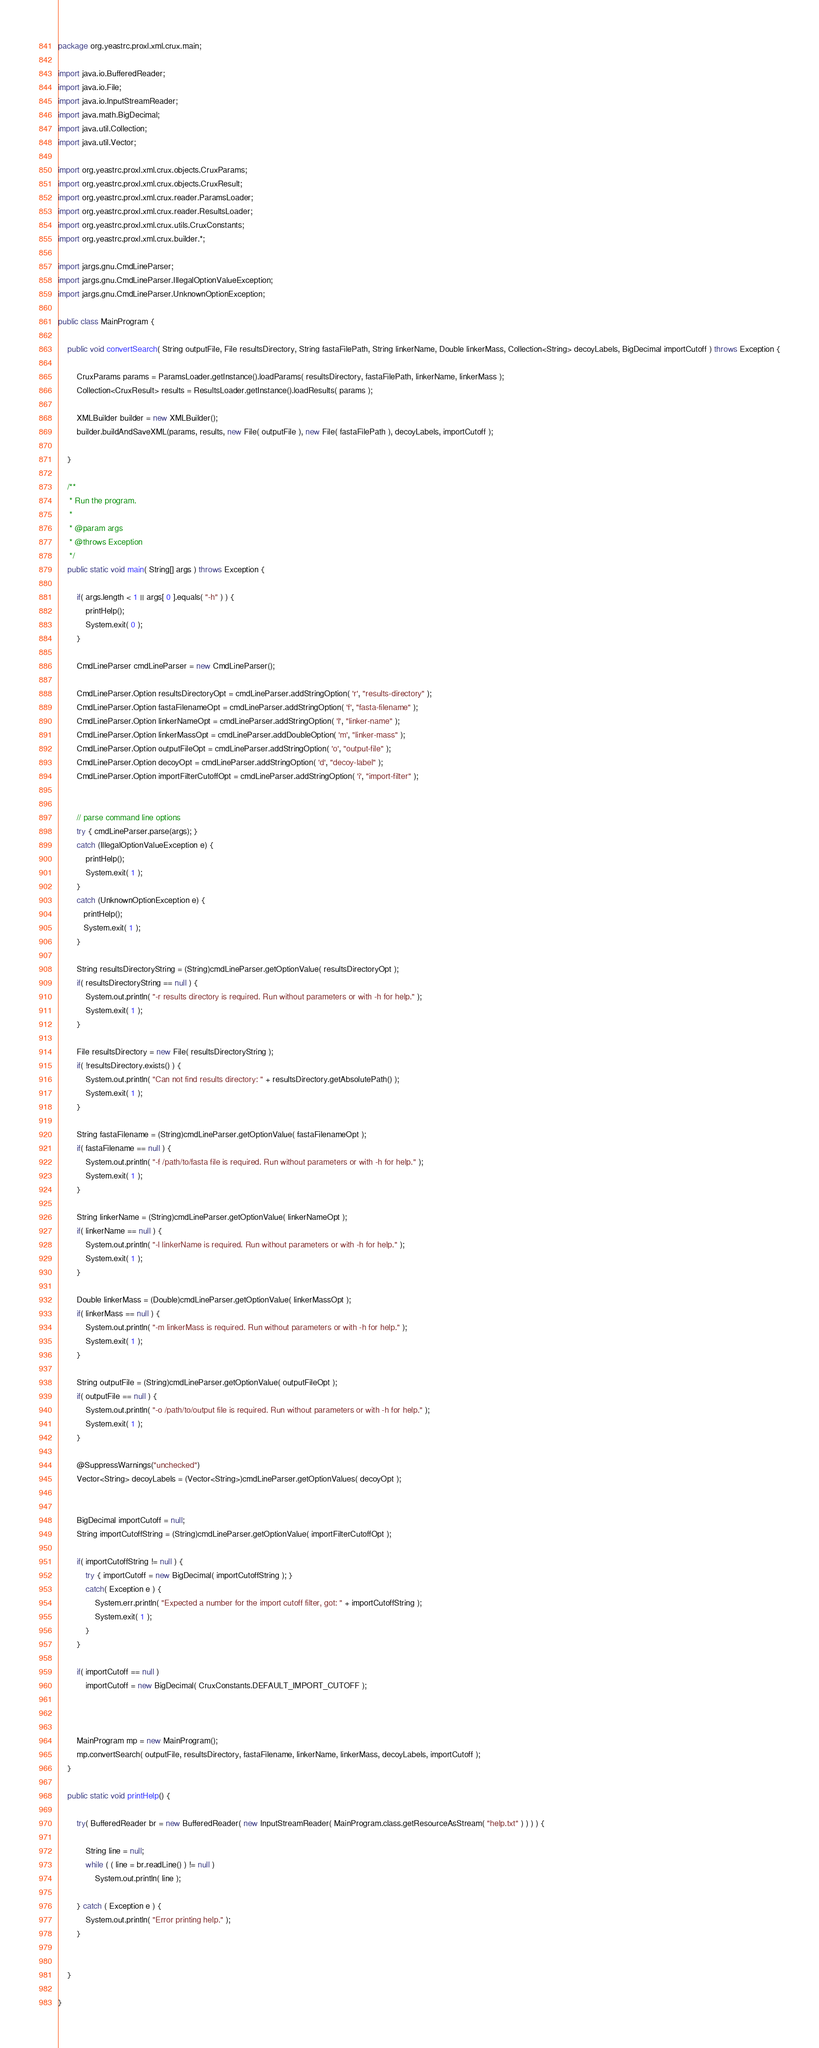Convert code to text. <code><loc_0><loc_0><loc_500><loc_500><_Java_>package org.yeastrc.proxl.xml.crux.main;

import java.io.BufferedReader;
import java.io.File;
import java.io.InputStreamReader;
import java.math.BigDecimal;
import java.util.Collection;
import java.util.Vector;

import org.yeastrc.proxl.xml.crux.objects.CruxParams;
import org.yeastrc.proxl.xml.crux.objects.CruxResult;
import org.yeastrc.proxl.xml.crux.reader.ParamsLoader;
import org.yeastrc.proxl.xml.crux.reader.ResultsLoader;
import org.yeastrc.proxl.xml.crux.utils.CruxConstants;
import org.yeastrc.proxl.xml.crux.builder.*;

import jargs.gnu.CmdLineParser;
import jargs.gnu.CmdLineParser.IllegalOptionValueException;
import jargs.gnu.CmdLineParser.UnknownOptionException;

public class MainProgram {

	public void convertSearch( String outputFile, File resultsDirectory, String fastaFilePath, String linkerName, Double linkerMass, Collection<String> decoyLabels, BigDecimal importCutoff ) throws Exception {
		
		CruxParams params = ParamsLoader.getInstance().loadParams( resultsDirectory, fastaFilePath, linkerName, linkerMass );
		Collection<CruxResult> results = ResultsLoader.getInstance().loadResults( params );
		
		XMLBuilder builder = new XMLBuilder();
		builder.buildAndSaveXML(params, results, new File( outputFile ), new File( fastaFilePath ), decoyLabels, importCutoff ); 
		
	}
	
	/**
	 * Run the program.
	 * 
	 * @param args
	 * @throws Exception
	 */
	public static void main( String[] args ) throws Exception {
		
		if( args.length < 1 || args[ 0 ].equals( "-h" ) ) {
			printHelp();
			System.exit( 0 );
		}
		
		CmdLineParser cmdLineParser = new CmdLineParser();
        
		CmdLineParser.Option resultsDirectoryOpt = cmdLineParser.addStringOption( 'r', "results-directory" );	
		CmdLineParser.Option fastaFilenameOpt = cmdLineParser.addStringOption( 'f', "fasta-filename" );	
		CmdLineParser.Option linkerNameOpt = cmdLineParser.addStringOption( 'l', "linker-name" );	
		CmdLineParser.Option linkerMassOpt = cmdLineParser.addDoubleOption( 'm', "linker-mass" );
		CmdLineParser.Option outputFileOpt = cmdLineParser.addStringOption( 'o', "output-file" );	
		CmdLineParser.Option decoyOpt = cmdLineParser.addStringOption( 'd', "decoy-label" );	
		CmdLineParser.Option importFilterCutoffOpt = cmdLineParser.addStringOption( 'i', "import-filter" );


        // parse command line options
        try { cmdLineParser.parse(args); }
        catch (IllegalOptionValueException e) {
        	printHelp();
            System.exit( 1 );
        }
        catch (UnknownOptionException e) {
           printHelp();
           System.exit( 1 );
        }
        
        String resultsDirectoryString = (String)cmdLineParser.getOptionValue( resultsDirectoryOpt );
        if( resultsDirectoryString == null ) {
        	System.out.println( "-r results directory is required. Run without parameters or with -h for help." );
        	System.exit( 1 );
        }
        
        File resultsDirectory = new File( resultsDirectoryString );
        if( !resultsDirectory.exists() ) {
        	System.out.println( "Can not find results directory: " + resultsDirectory.getAbsolutePath() );
        	System.exit( 1 );
        }
        
        String fastaFilename = (String)cmdLineParser.getOptionValue( fastaFilenameOpt );
        if( fastaFilename == null ) {
        	System.out.println( "-f /path/to/fasta file is required. Run without parameters or with -h for help." );
        	System.exit( 1 );
        }
        
        String linkerName = (String)cmdLineParser.getOptionValue( linkerNameOpt );
        if( linkerName == null ) {
        	System.out.println( "-l linkerName is required. Run without parameters or with -h for help." );
        	System.exit( 1 );
        }
        
        Double linkerMass = (Double)cmdLineParser.getOptionValue( linkerMassOpt );
        if( linkerMass == null ) {
        	System.out.println( "-m linkerMass is required. Run without parameters or with -h for help." );
        	System.exit( 1 );
        }
        
        String outputFile = (String)cmdLineParser.getOptionValue( outputFileOpt );
        if( outputFile == null ) {
        	System.out.println( "-o /path/to/output file is required. Run without parameters or with -h for help." );
        	System.exit( 1 );
        }
        
        @SuppressWarnings("unchecked")
		Vector<String> decoyLabels = (Vector<String>)cmdLineParser.getOptionValues( decoyOpt );
        
        
        BigDecimal importCutoff = null;
        String importCutoffString = (String)cmdLineParser.getOptionValue( importFilterCutoffOpt );
        
        if( importCutoffString != null ) {
	        try { importCutoff = new BigDecimal( importCutoffString ); }
	        catch( Exception e ) {
	        	System.err.println( "Expected a number for the import cutoff filter, got: " + importCutoffString );
	        	System.exit( 1 );
	        }
        }
        
        if( importCutoff == null )
        	importCutoff = new BigDecimal( CruxConstants.DEFAULT_IMPORT_CUTOFF );
        
        
        
		MainProgram mp = new MainProgram();
		mp.convertSearch( outputFile, resultsDirectory, fastaFilename, linkerName, linkerMass, decoyLabels, importCutoff );
	}
	
	public static void printHelp() {
				
		try( BufferedReader br = new BufferedReader( new InputStreamReader( MainProgram.class.getResourceAsStream( "help.txt" ) ) ) ) {
			
			String line = null;
			while ( ( line = br.readLine() ) != null )
				System.out.println( line );				
			
		} catch ( Exception e ) {
			System.out.println( "Error printing help." );
		}
		
		
	}
	
}
</code> 